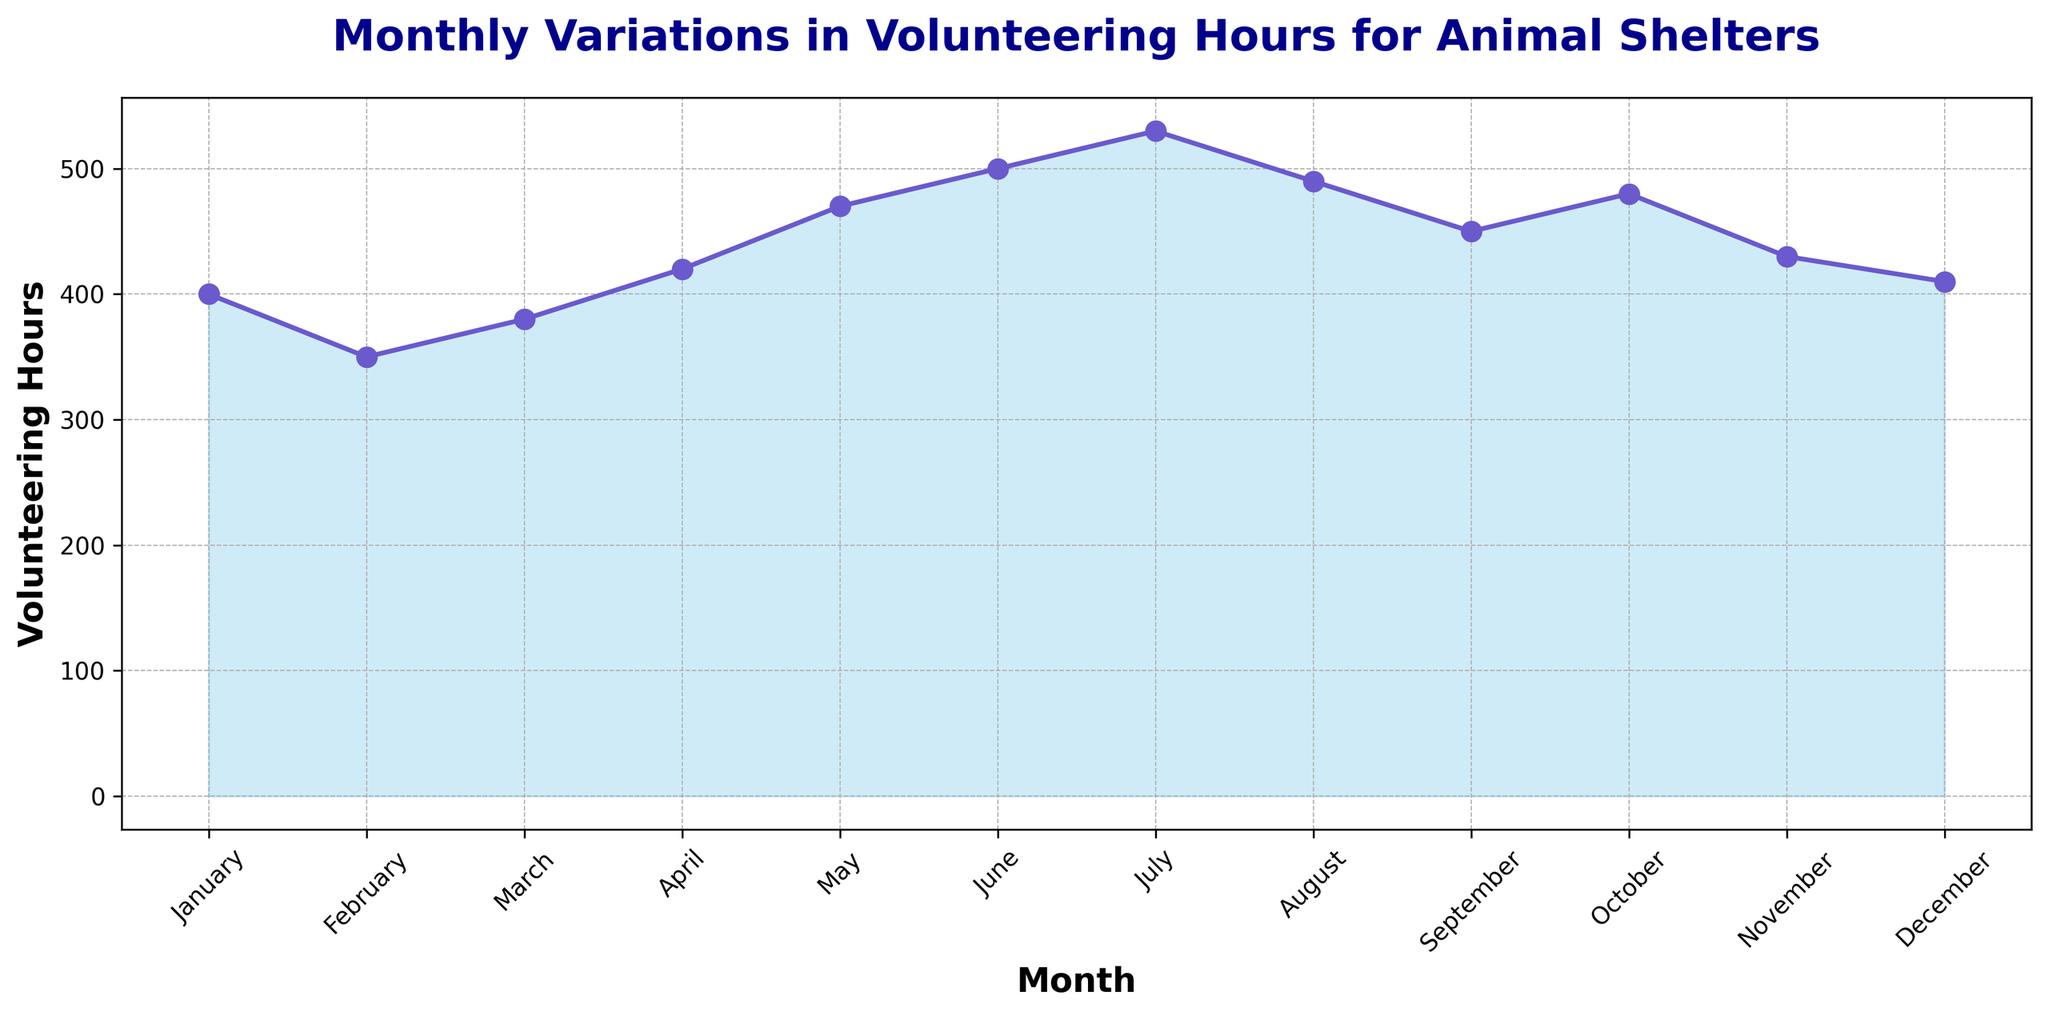What is the range of volunteering hours observed throughout the year? The range is calculated by subtracting the minimum value from the maximum value. Here, the minimum is 350 hours (February) and the maximum is 530 hours (July). The range is 530 - 350 = 180 hours.
Answer: 180 hours Which month had the lowest number of volunteering hours, and how many hours were recorded? By visually inspecting the plot, February had the lowest number of volunteering hours, with 350 hours.
Answer: February, 350 hours During which month(s) did the volunteering hours peak, and what was the maximum value? The plot shows that July had the highest peak in volunteering hours, with a maximum of 530 hours.
Answer: July, 530 hours In terms of volunteering hours, how does January compare with December? January recorded 400 hours, while December recorded 410 hours. January had fewer volunteering hours than December.
Answer: January had fewer hours What's the average volunteering hours per month for the first half of the year (January through June)? Add the hours for January through June: 400 + 350 + 380 + 420 + 470 + 500 = 2520. There are 6 months, so the average is 2520 / 6 = 420 hours.
Answer: 420 hours How much did the volunteering hours increase from February to March? March had 380 hours, while February had 350 hours. The increase is 380 - 350 = 30 hours.
Answer: 30 hours Which quarter of the year (3-month periods) had the highest average volunteering hours? Calculate the average for each quarter:
Q1: (400 + 350 + 380)/3 = 376.67 hours
Q2: (420 + 470 + 500)/3 = 463.33 hours
Q3: (530 + 490 + 450)/3 = 490 hours
Q4: (480 + 430 + 410)/3 = 440 hours
Q3 had the highest average at 490 hours.
Answer: Q3 Compare the total volunteering hours for the first half of the year with the second half. Sum the hours for both halves:
First half (Jan-Jun): 400 + 350 + 380 + 420 + 470 + 500 = 2520 hours.
Second half (Jul-Dec): 530 + 490 + 450 + 480 + 430 + 410 = 2790 hours.
The second half had more volunteering hours.
Answer: Second half had more What color is used to fill the area under the line, and what does it indicate? The area under the line is filled with a light blue (skyblue) color, indicating the volunteering hours by month.
Answer: Light blue, volunteering hours What trend can be observed in volunteering hours from March to July? The trend shows a consistent increase in volunteering hours starting from March (380 hours) and peaking in July (530 hours).
Answer: Consistent increase 